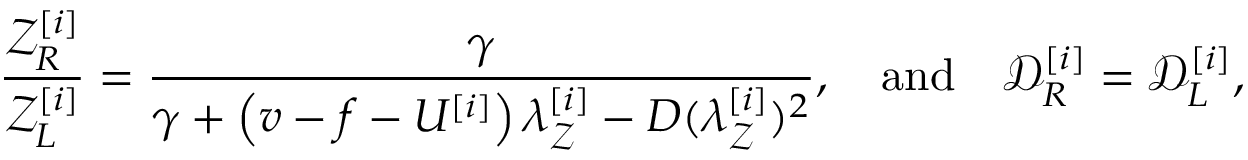Convert formula to latex. <formula><loc_0><loc_0><loc_500><loc_500>\frac { \mathcal { Z } _ { R } ^ { [ i ] } } { \mathcal { Z } _ { L } ^ { [ i ] } } = \frac { \gamma } { \gamma + \left ( v - f - U ^ { [ i ] } \right ) \lambda _ { \mathcal { Z } } ^ { [ i ] } - D ( \lambda _ { \mathcal { Z } } ^ { [ i ] } ) ^ { 2 } } , \quad a n d \quad \mathcal { D } _ { R } ^ { [ i ] } = \mathcal { D } _ { L } ^ { [ i ] } ,</formula> 